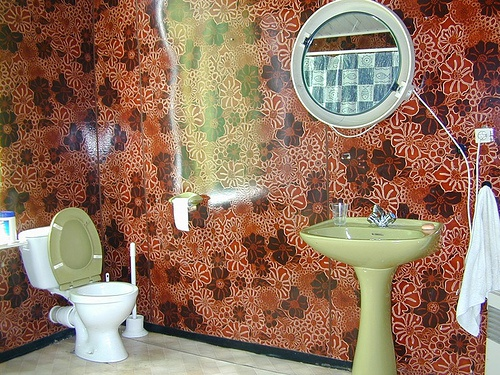Describe the objects in this image and their specific colors. I can see toilet in brown, lightgray, olive, darkgray, and lightblue tones, sink in brown, olive, khaki, and tan tones, and cup in brown, darkgray, gray, and lightgray tones in this image. 